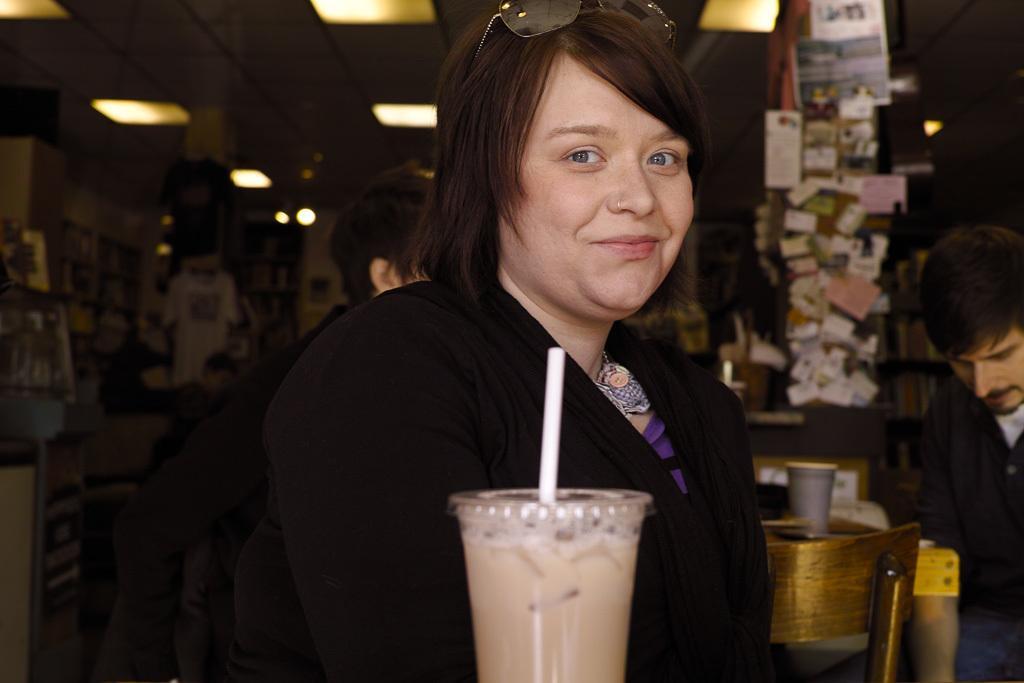Can you describe this image briefly? In this image in the front there is a glass and in the glass there is a straw. In the center there is a woman smiling and there are persons and in the background there are papers, lights and there is an object in the center which is golden in colour. On the left side there is a cloth hanging and there are lights on the top. 